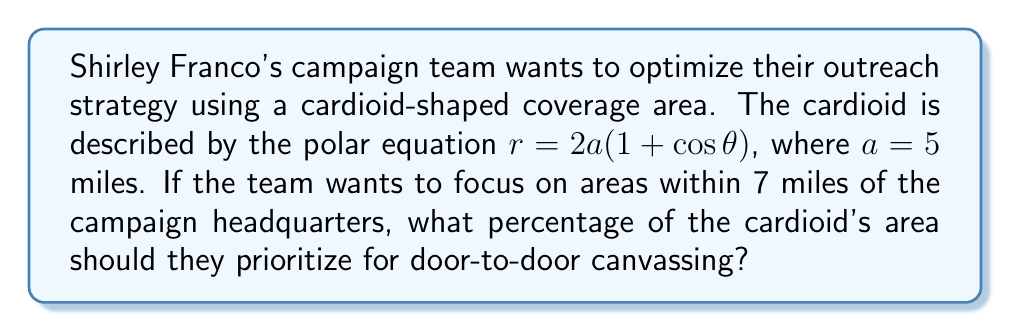What is the answer to this math problem? To solve this problem, we need to follow these steps:

1) First, let's calculate the total area of the cardioid. The area of a cardioid is given by the formula:

   $A_{total} = 6\pi a^2$

   Where $a = 5$ miles. So,
   
   $A_{total} = 6\pi (5^2) = 150\pi$ square miles

2) Now, we need to find the area of the inner region within 7 miles. This region is not a complete circle due to the shape of the cardioid. However, we can approximate it as a circle for this calculation.

   The area of this circle would be:
   
   $A_{inner} = \pi r^2 = \pi (7^2) = 49\pi$ square miles

3) To find the percentage of the cardioid's area that should be prioritized, we divide the inner area by the total area and multiply by 100:

   $Percentage = \frac{A_{inner}}{A_{total}} \times 100\%$

   $= \frac{49\pi}{150\pi} \times 100\%$

   $= \frac{49}{150} \times 100\%$

   $= 0.3266... \times 100\%$

   $\approx 32.67\%$

Therefore, the campaign team should prioritize approximately 32.67% of the cardioid's area for door-to-door canvassing.
Answer: 32.67% 